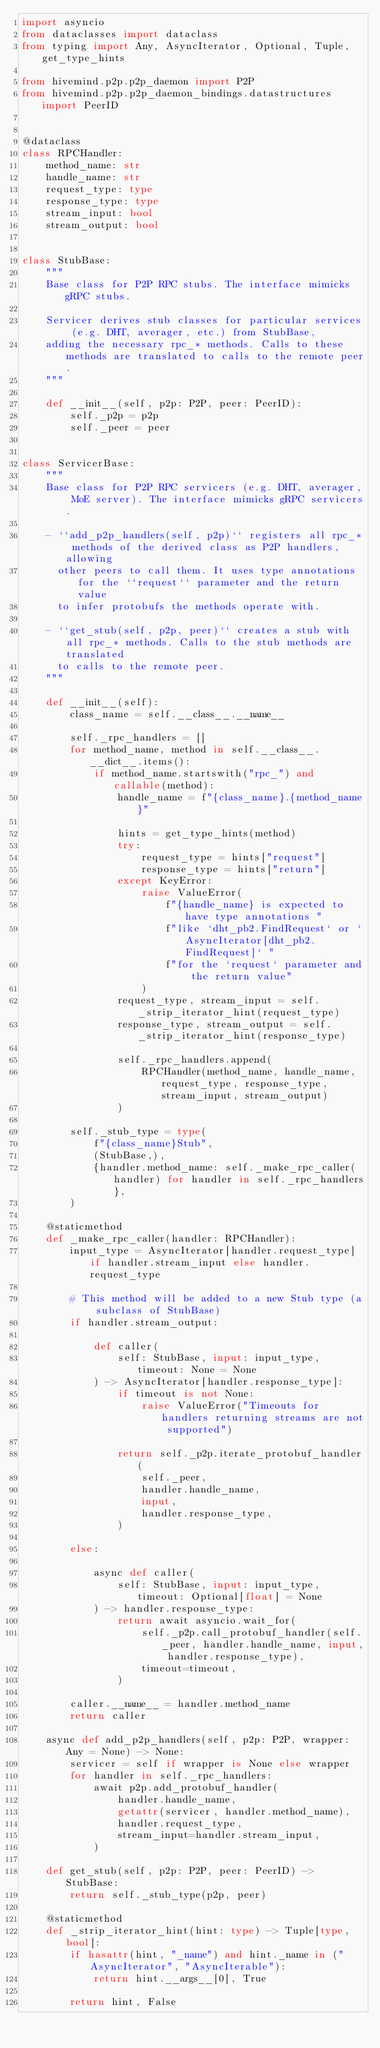Convert code to text. <code><loc_0><loc_0><loc_500><loc_500><_Python_>import asyncio
from dataclasses import dataclass
from typing import Any, AsyncIterator, Optional, Tuple, get_type_hints

from hivemind.p2p.p2p_daemon import P2P
from hivemind.p2p.p2p_daemon_bindings.datastructures import PeerID


@dataclass
class RPCHandler:
    method_name: str
    handle_name: str
    request_type: type
    response_type: type
    stream_input: bool
    stream_output: bool


class StubBase:
    """
    Base class for P2P RPC stubs. The interface mimicks gRPC stubs.

    Servicer derives stub classes for particular services (e.g. DHT, averager, etc.) from StubBase,
    adding the necessary rpc_* methods. Calls to these methods are translated to calls to the remote peer.
    """

    def __init__(self, p2p: P2P, peer: PeerID):
        self._p2p = p2p
        self._peer = peer


class ServicerBase:
    """
    Base class for P2P RPC servicers (e.g. DHT, averager, MoE server). The interface mimicks gRPC servicers.

    - ``add_p2p_handlers(self, p2p)`` registers all rpc_* methods of the derived class as P2P handlers, allowing
      other peers to call them. It uses type annotations for the ``request`` parameter and the return value
      to infer protobufs the methods operate with.

    - ``get_stub(self, p2p, peer)`` creates a stub with all rpc_* methods. Calls to the stub methods are translated
      to calls to the remote peer.
    """

    def __init__(self):
        class_name = self.__class__.__name__

        self._rpc_handlers = []
        for method_name, method in self.__class__.__dict__.items():
            if method_name.startswith("rpc_") and callable(method):
                handle_name = f"{class_name}.{method_name}"

                hints = get_type_hints(method)
                try:
                    request_type = hints["request"]
                    response_type = hints["return"]
                except KeyError:
                    raise ValueError(
                        f"{handle_name} is expected to have type annotations "
                        f"like `dht_pb2.FindRequest` or `AsyncIterator[dht_pb2.FindRequest]` "
                        f"for the `request` parameter and the return value"
                    )
                request_type, stream_input = self._strip_iterator_hint(request_type)
                response_type, stream_output = self._strip_iterator_hint(response_type)

                self._rpc_handlers.append(
                    RPCHandler(method_name, handle_name, request_type, response_type, stream_input, stream_output)
                )

        self._stub_type = type(
            f"{class_name}Stub",
            (StubBase,),
            {handler.method_name: self._make_rpc_caller(handler) for handler in self._rpc_handlers},
        )

    @staticmethod
    def _make_rpc_caller(handler: RPCHandler):
        input_type = AsyncIterator[handler.request_type] if handler.stream_input else handler.request_type

        # This method will be added to a new Stub type (a subclass of StubBase)
        if handler.stream_output:

            def caller(
                self: StubBase, input: input_type, timeout: None = None
            ) -> AsyncIterator[handler.response_type]:
                if timeout is not None:
                    raise ValueError("Timeouts for handlers returning streams are not supported")

                return self._p2p.iterate_protobuf_handler(
                    self._peer,
                    handler.handle_name,
                    input,
                    handler.response_type,
                )

        else:

            async def caller(
                self: StubBase, input: input_type, timeout: Optional[float] = None
            ) -> handler.response_type:
                return await asyncio.wait_for(
                    self._p2p.call_protobuf_handler(self._peer, handler.handle_name, input, handler.response_type),
                    timeout=timeout,
                )

        caller.__name__ = handler.method_name
        return caller

    async def add_p2p_handlers(self, p2p: P2P, wrapper: Any = None) -> None:
        servicer = self if wrapper is None else wrapper
        for handler in self._rpc_handlers:
            await p2p.add_protobuf_handler(
                handler.handle_name,
                getattr(servicer, handler.method_name),
                handler.request_type,
                stream_input=handler.stream_input,
            )

    def get_stub(self, p2p: P2P, peer: PeerID) -> StubBase:
        return self._stub_type(p2p, peer)

    @staticmethod
    def _strip_iterator_hint(hint: type) -> Tuple[type, bool]:
        if hasattr(hint, "_name") and hint._name in ("AsyncIterator", "AsyncIterable"):
            return hint.__args__[0], True

        return hint, False
</code> 